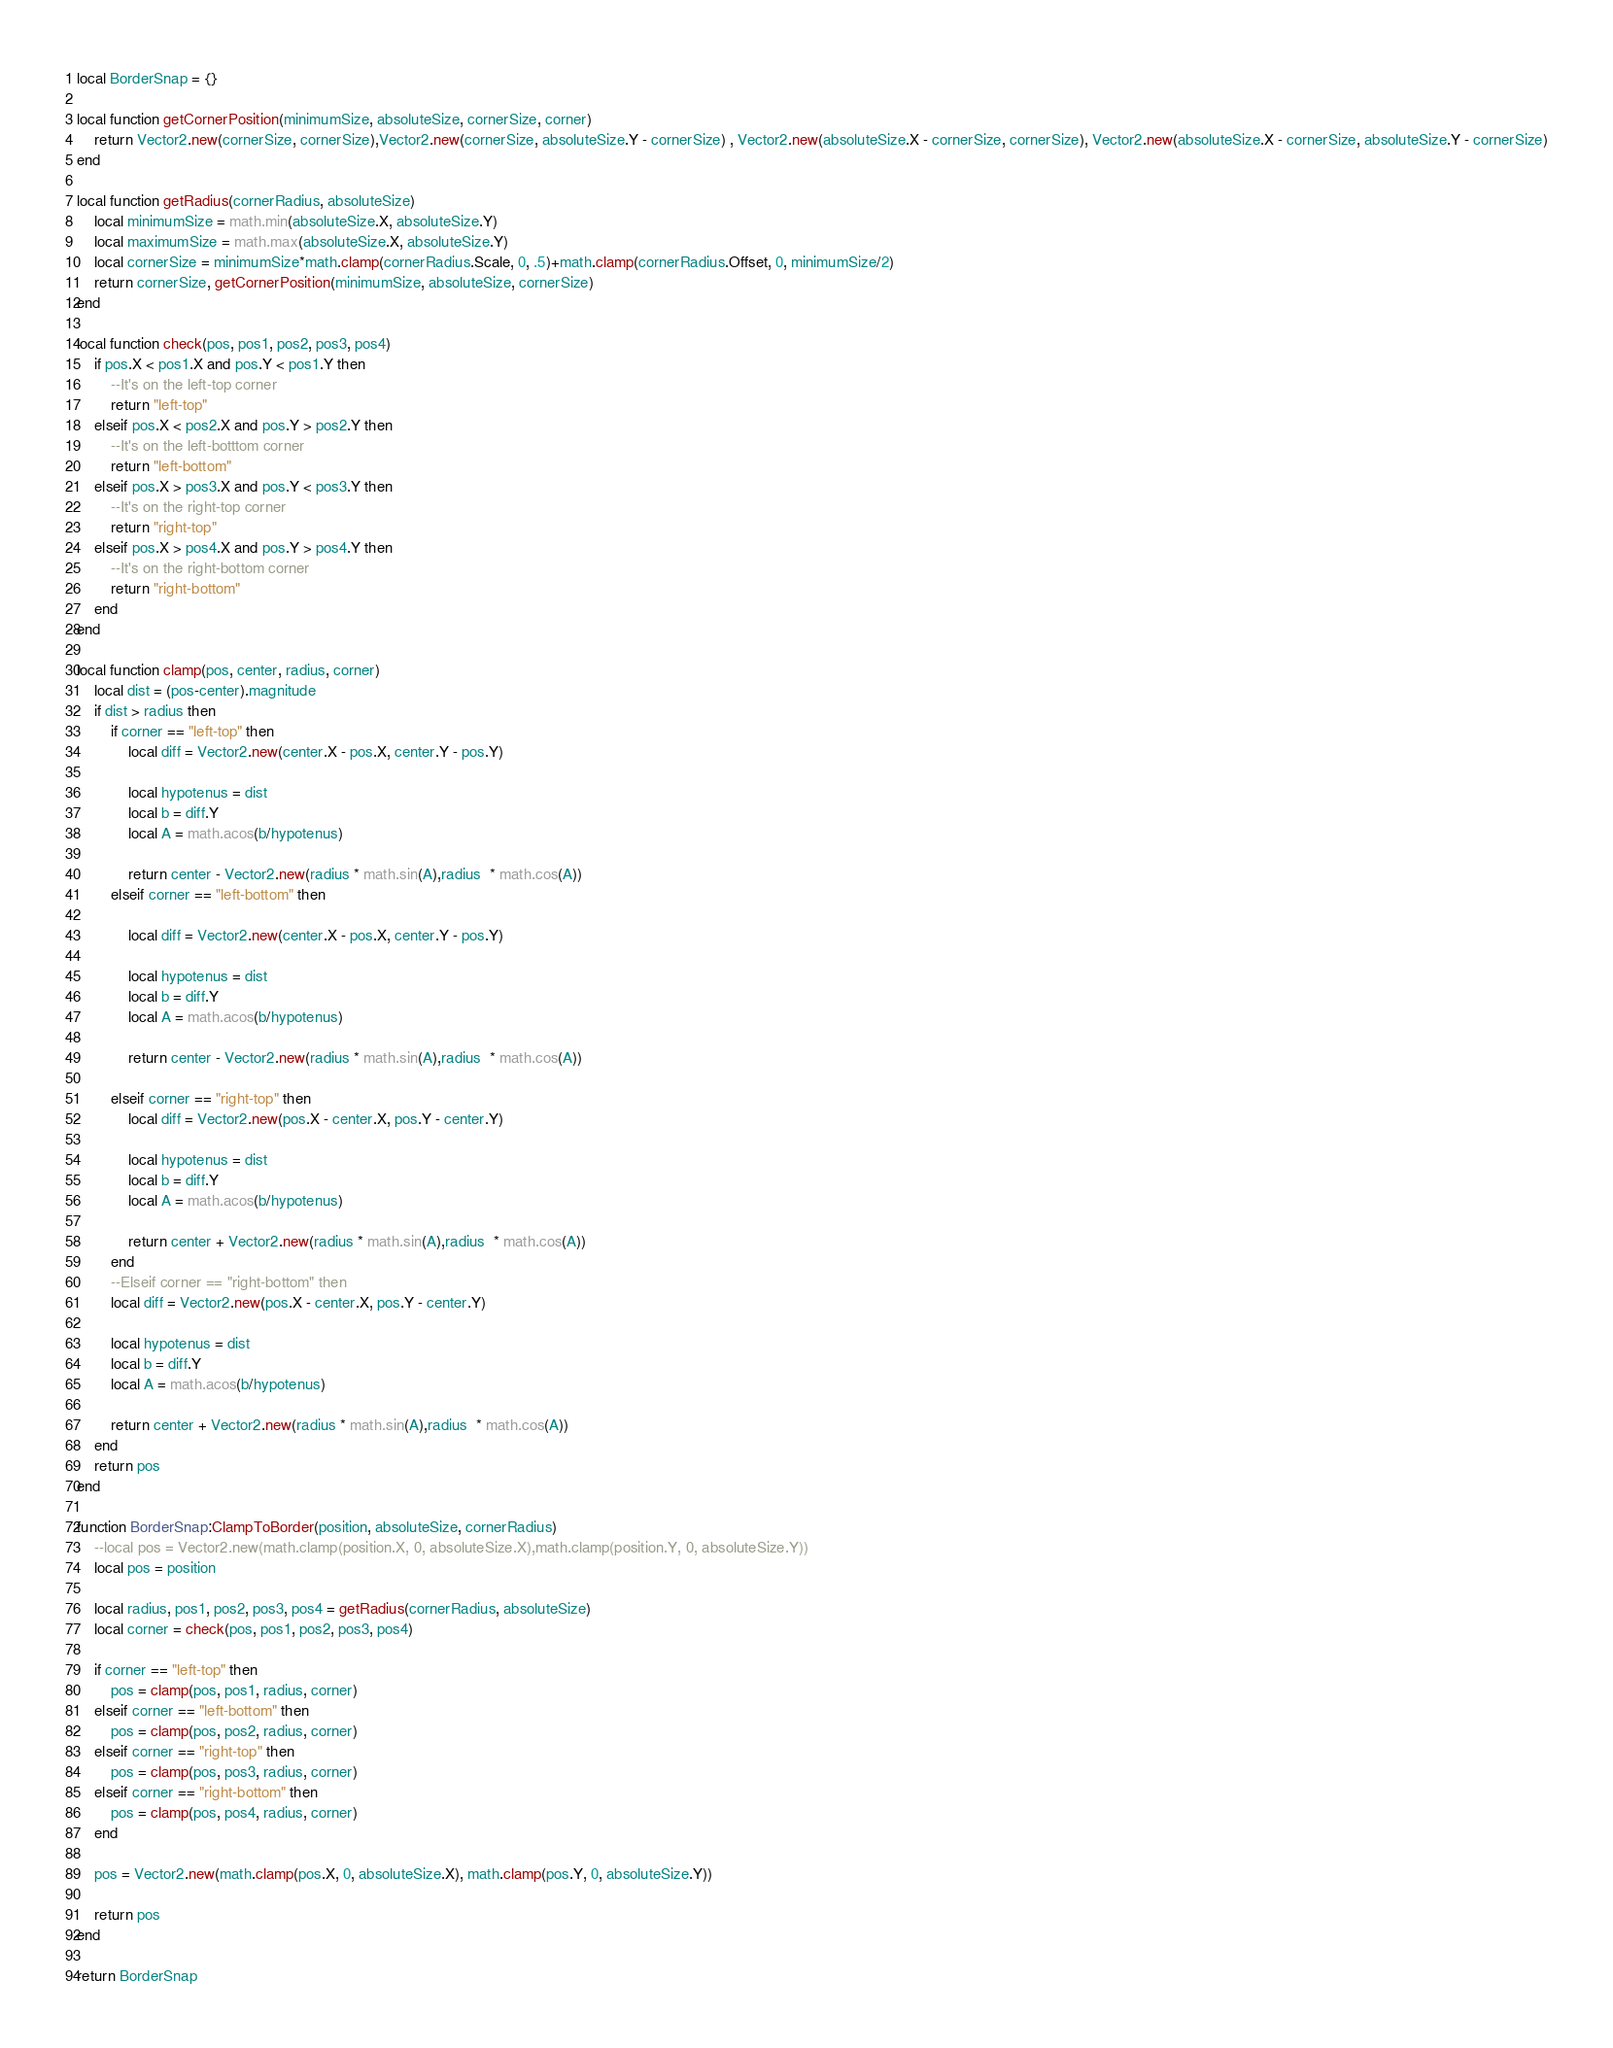Convert code to text. <code><loc_0><loc_0><loc_500><loc_500><_Lua_>local BorderSnap = {}

local function getCornerPosition(minimumSize, absoluteSize, cornerSize, corner)
	return Vector2.new(cornerSize, cornerSize),Vector2.new(cornerSize, absoluteSize.Y - cornerSize) , Vector2.new(absoluteSize.X - cornerSize, cornerSize), Vector2.new(absoluteSize.X - cornerSize, absoluteSize.Y - cornerSize)
end

local function getRadius(cornerRadius, absoluteSize)
	local minimumSize = math.min(absoluteSize.X, absoluteSize.Y)
	local maximumSize = math.max(absoluteSize.X, absoluteSize.Y)
	local cornerSize = minimumSize*math.clamp(cornerRadius.Scale, 0, .5)+math.clamp(cornerRadius.Offset, 0, minimumSize/2)
	return cornerSize, getCornerPosition(minimumSize, absoluteSize, cornerSize)
end

local function check(pos, pos1, pos2, pos3, pos4)
	if pos.X < pos1.X and pos.Y < pos1.Y then
		--It's on the left-top corner
		return "left-top"
	elseif pos.X < pos2.X and pos.Y > pos2.Y then
		--It's on the left-botttom corner
		return "left-bottom"
	elseif pos.X > pos3.X and pos.Y < pos3.Y then
		--It's on the right-top corner
		return "right-top"
	elseif pos.X > pos4.X and pos.Y > pos4.Y then
		--It's on the right-bottom corner
		return "right-bottom"
	end
end

local function clamp(pos, center, radius, corner)
	local dist = (pos-center).magnitude
	if dist > radius then
		if corner == "left-top" then
			local diff = Vector2.new(center.X - pos.X, center.Y - pos.Y)

			local hypotenus = dist
			local b = diff.Y
			local A = math.acos(b/hypotenus)

			return center - Vector2.new(radius * math.sin(A),radius  * math.cos(A))
		elseif corner == "left-bottom" then

			local diff = Vector2.new(center.X - pos.X, center.Y - pos.Y)

			local hypotenus = dist
			local b = diff.Y
			local A = math.acos(b/hypotenus)

			return center - Vector2.new(radius * math.sin(A),radius  * math.cos(A))

		elseif corner == "right-top" then
			local diff = Vector2.new(pos.X - center.X, pos.Y - center.Y)

			local hypotenus = dist
			local b = diff.Y
			local A = math.acos(b/hypotenus)

			return center + Vector2.new(radius * math.sin(A),radius  * math.cos(A))
		end
		--Elseif corner == "right-bottom" then
		local diff = Vector2.new(pos.X - center.X, pos.Y - center.Y)

		local hypotenus = dist
		local b = diff.Y
		local A = math.acos(b/hypotenus)

		return center + Vector2.new(radius * math.sin(A),radius  * math.cos(A))
	end
	return pos
end

function BorderSnap:ClampToBorder(position, absoluteSize, cornerRadius)
	--local pos = Vector2.new(math.clamp(position.X, 0, absoluteSize.X),math.clamp(position.Y, 0, absoluteSize.Y))
	local pos = position
	
	local radius, pos1, pos2, pos3, pos4 = getRadius(cornerRadius, absoluteSize)
	local corner = check(pos, pos1, pos2, pos3, pos4)
	
	if corner == "left-top" then
		pos = clamp(pos, pos1, radius, corner)
	elseif corner == "left-bottom" then
		pos = clamp(pos, pos2, radius, corner)
	elseif corner == "right-top" then
		pos = clamp(pos, pos3, radius, corner)
	elseif corner == "right-bottom" then
		pos = clamp(pos, pos4, radius, corner)
	end
	
	pos = Vector2.new(math.clamp(pos.X, 0, absoluteSize.X), math.clamp(pos.Y, 0, absoluteSize.Y))
	
	return pos
end

return BorderSnap
</code> 